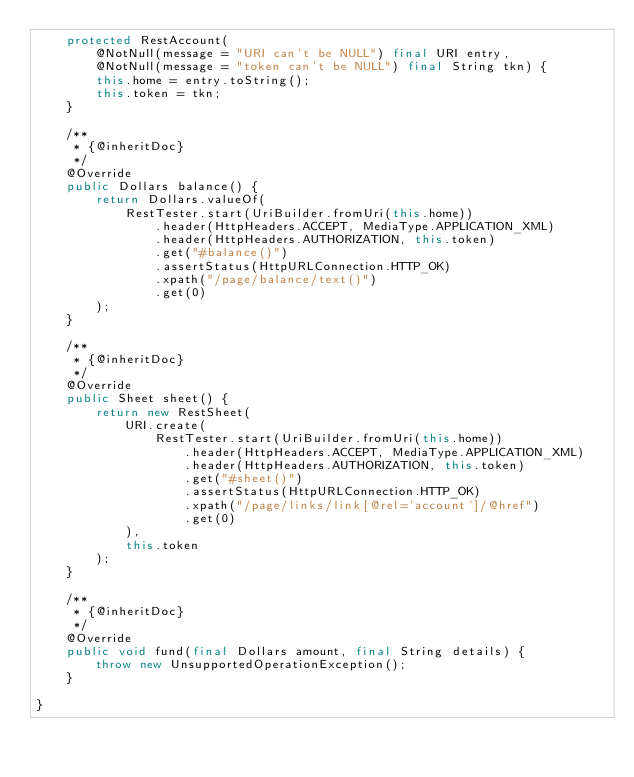Convert code to text. <code><loc_0><loc_0><loc_500><loc_500><_Java_>    protected RestAccount(
        @NotNull(message = "URI can't be NULL") final URI entry,
        @NotNull(message = "token can't be NULL") final String tkn) {
        this.home = entry.toString();
        this.token = tkn;
    }

    /**
     * {@inheritDoc}
     */
    @Override
    public Dollars balance() {
        return Dollars.valueOf(
            RestTester.start(UriBuilder.fromUri(this.home))
                .header(HttpHeaders.ACCEPT, MediaType.APPLICATION_XML)
                .header(HttpHeaders.AUTHORIZATION, this.token)
                .get("#balance()")
                .assertStatus(HttpURLConnection.HTTP_OK)
                .xpath("/page/balance/text()")
                .get(0)
        );
    }

    /**
     * {@inheritDoc}
     */
    @Override
    public Sheet sheet() {
        return new RestSheet(
            URI.create(
                RestTester.start(UriBuilder.fromUri(this.home))
                    .header(HttpHeaders.ACCEPT, MediaType.APPLICATION_XML)
                    .header(HttpHeaders.AUTHORIZATION, this.token)
                    .get("#sheet()")
                    .assertStatus(HttpURLConnection.HTTP_OK)
                    .xpath("/page/links/link[@rel='account']/@href")
                    .get(0)
            ),
            this.token
        );
    }

    /**
     * {@inheritDoc}
     */
    @Override
    public void fund(final Dollars amount, final String details) {
        throw new UnsupportedOperationException();
    }

}
</code> 